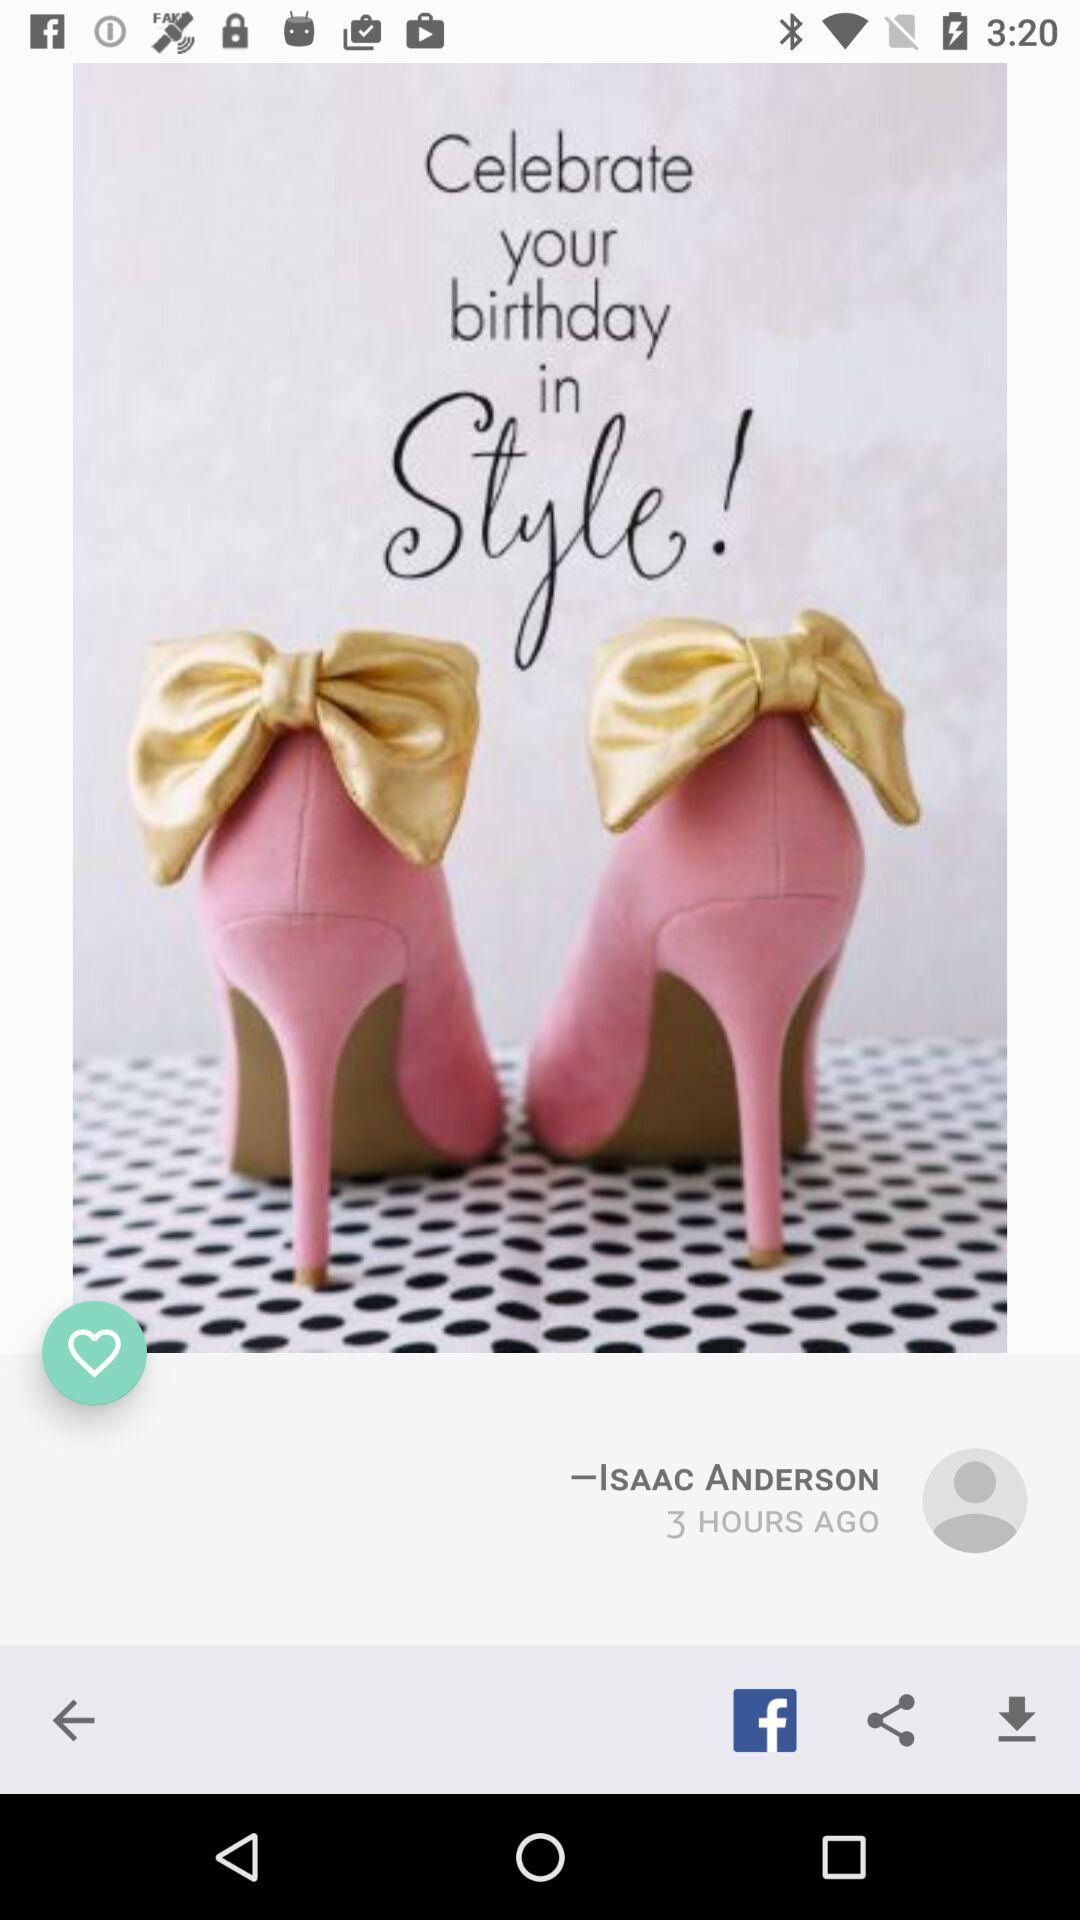How many hours ago was this post made?
Answer the question using a single word or phrase. 3 